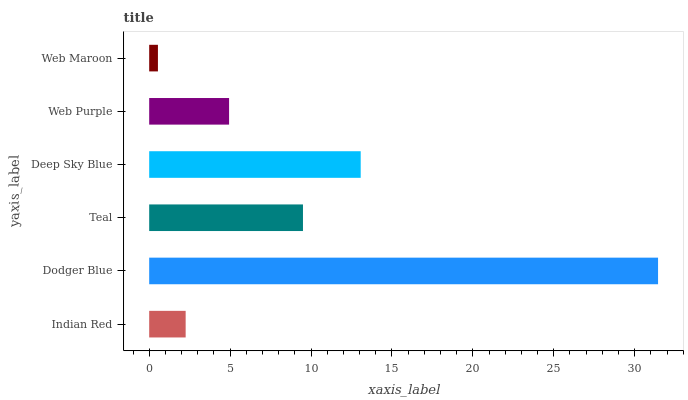Is Web Maroon the minimum?
Answer yes or no. Yes. Is Dodger Blue the maximum?
Answer yes or no. Yes. Is Teal the minimum?
Answer yes or no. No. Is Teal the maximum?
Answer yes or no. No. Is Dodger Blue greater than Teal?
Answer yes or no. Yes. Is Teal less than Dodger Blue?
Answer yes or no. Yes. Is Teal greater than Dodger Blue?
Answer yes or no. No. Is Dodger Blue less than Teal?
Answer yes or no. No. Is Teal the high median?
Answer yes or no. Yes. Is Web Purple the low median?
Answer yes or no. Yes. Is Web Maroon the high median?
Answer yes or no. No. Is Indian Red the low median?
Answer yes or no. No. 